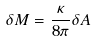Convert formula to latex. <formula><loc_0><loc_0><loc_500><loc_500>\delta M = \frac { \kappa } { 8 \pi } \delta A</formula> 